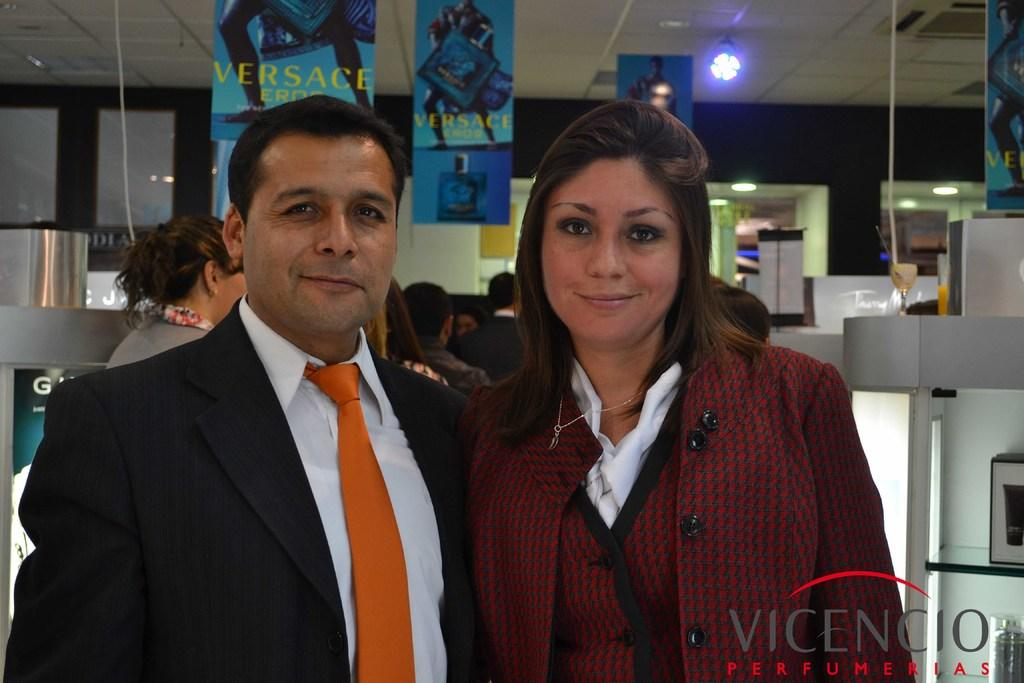How many people are present in the image? There are two people, a man and a woman, present in the image. What expressions do the man and woman have in the image? Both the man and the woman are smiling in the image. What can be seen in the background of the image? There is a group of people, lights, a roof, and some objects visible in the background of the image. What year is the ship mentioned in the image? There is no ship present in the image, so it is not possible to determine the year it is mentioned. 